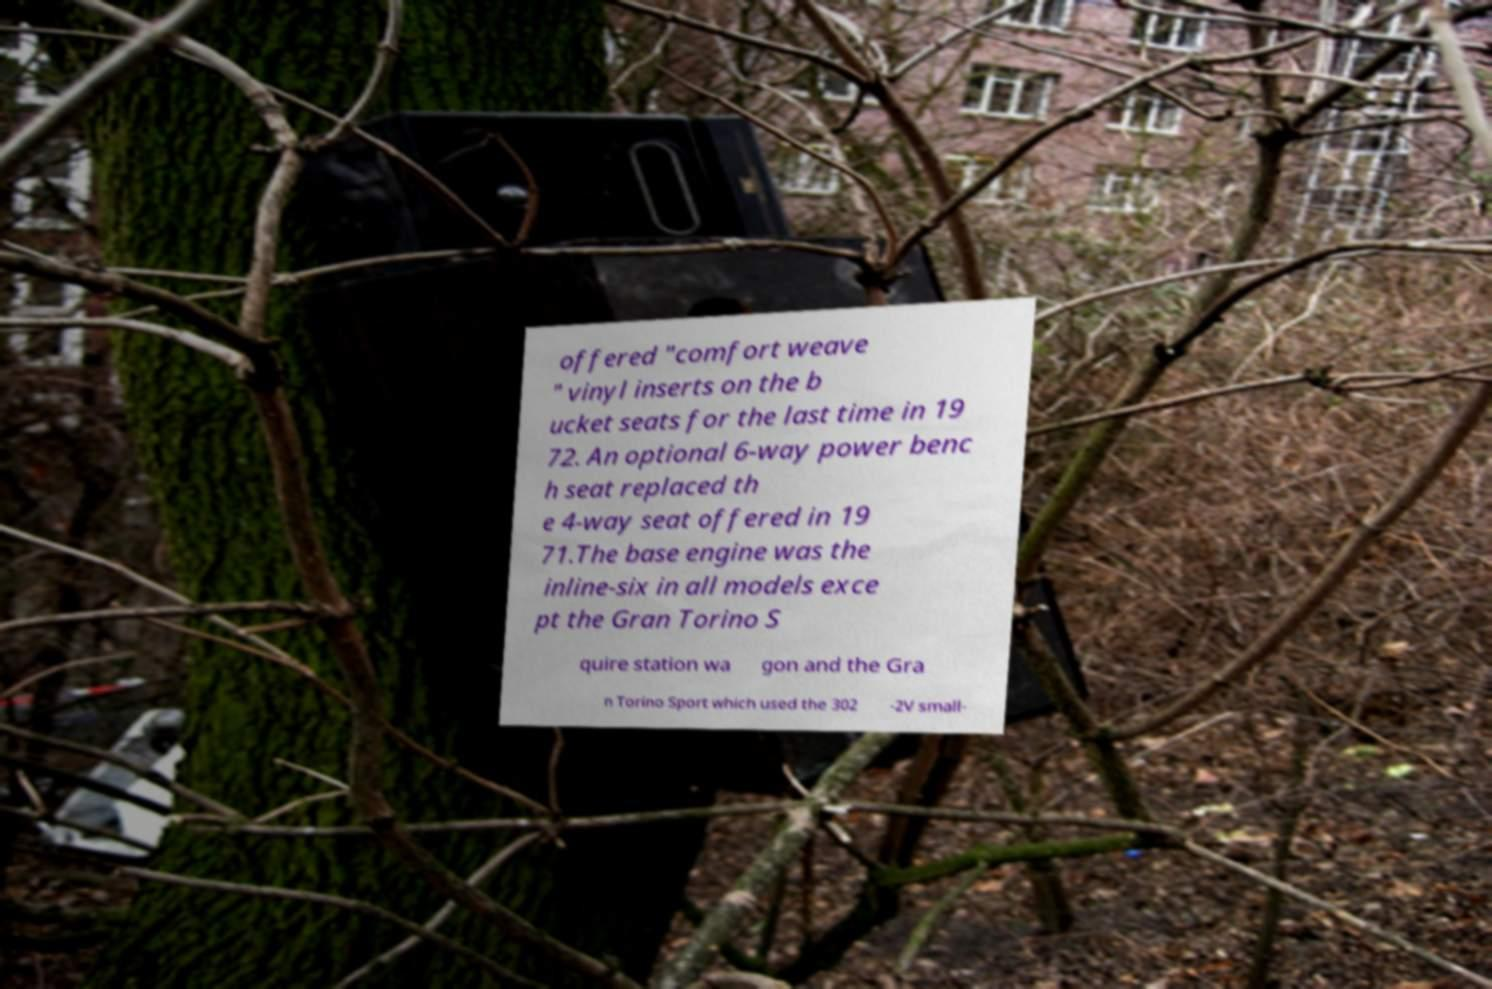There's text embedded in this image that I need extracted. Can you transcribe it verbatim? offered "comfort weave " vinyl inserts on the b ucket seats for the last time in 19 72. An optional 6-way power benc h seat replaced th e 4-way seat offered in 19 71.The base engine was the inline-six in all models exce pt the Gran Torino S quire station wa gon and the Gra n Torino Sport which used the 302 -2V small- 